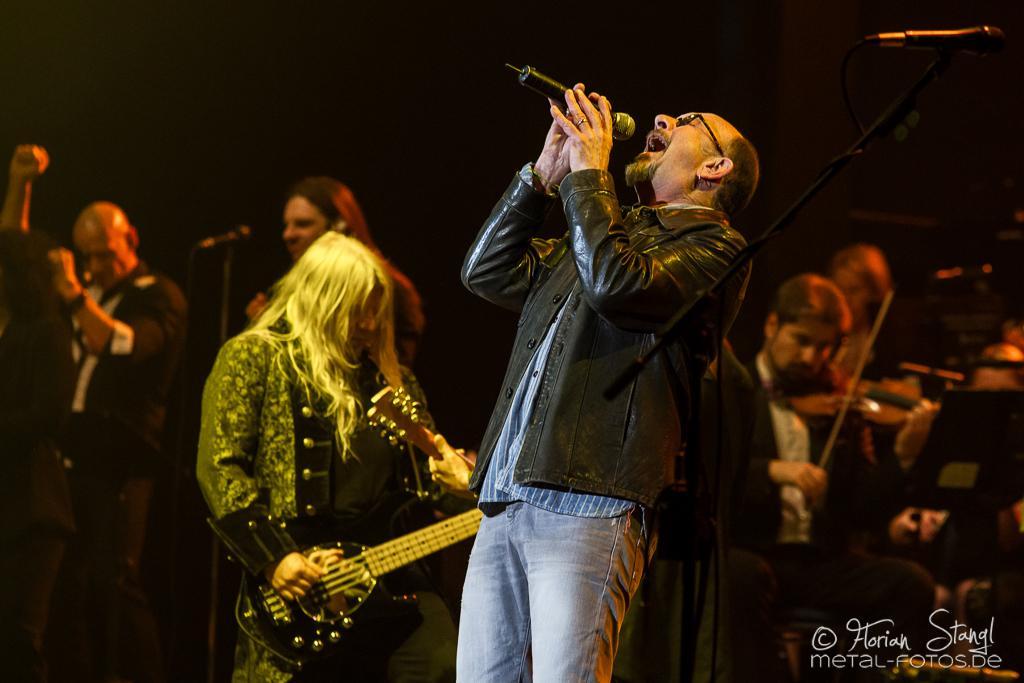Please provide a concise description of this image. This picture describes about group of musicians, A man is singing with the help of microphone, and another man is playing guitar, in the background we can see couple of people playing musical instruments. 